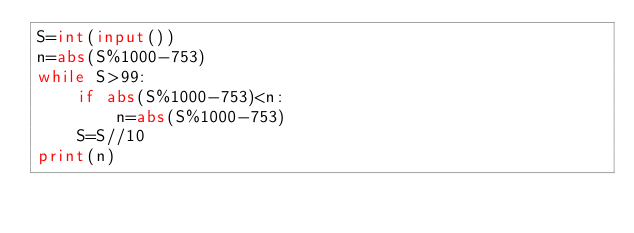<code> <loc_0><loc_0><loc_500><loc_500><_Python_>S=int(input())
n=abs(S%1000-753)
while S>99:
    if abs(S%1000-753)<n:
        n=abs(S%1000-753)
    S=S//10
print(n)</code> 